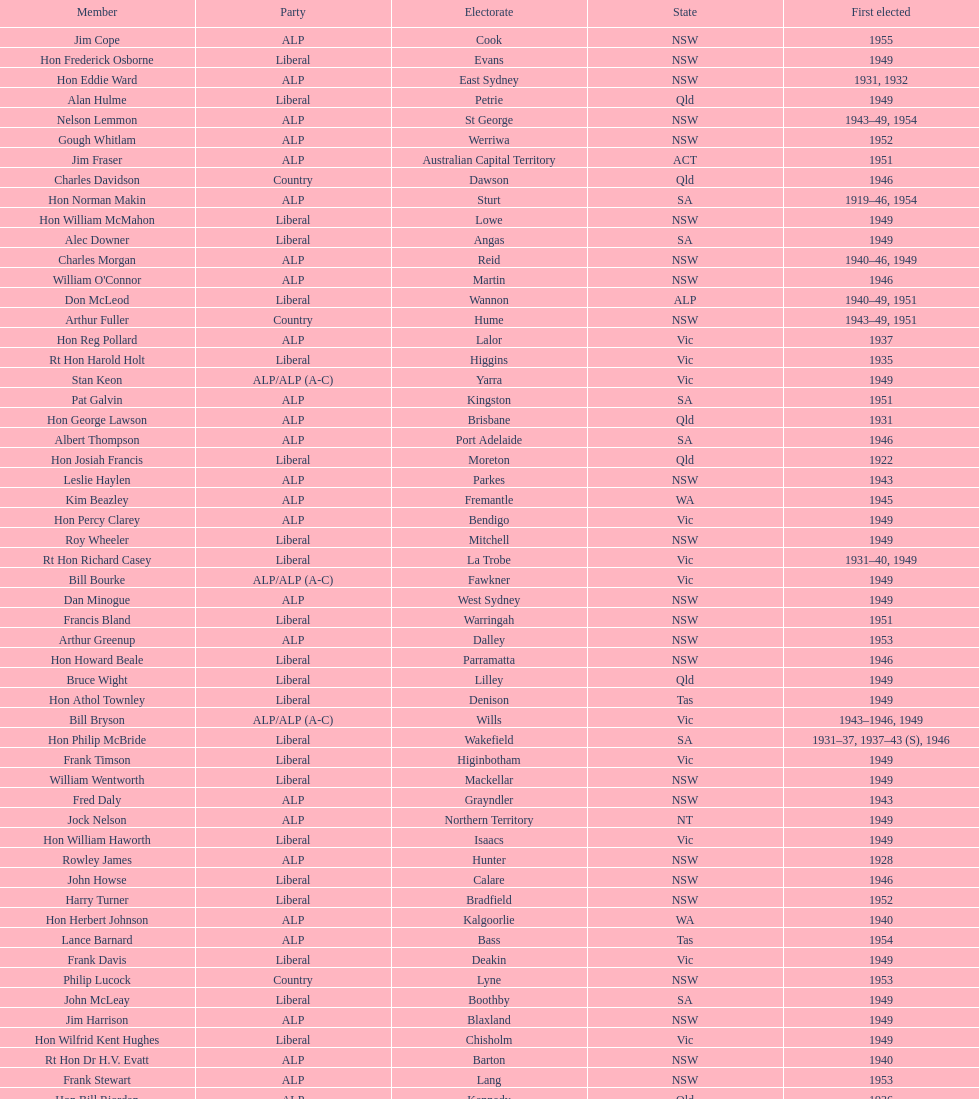Did tom burke run as country or alp party? ALP. 